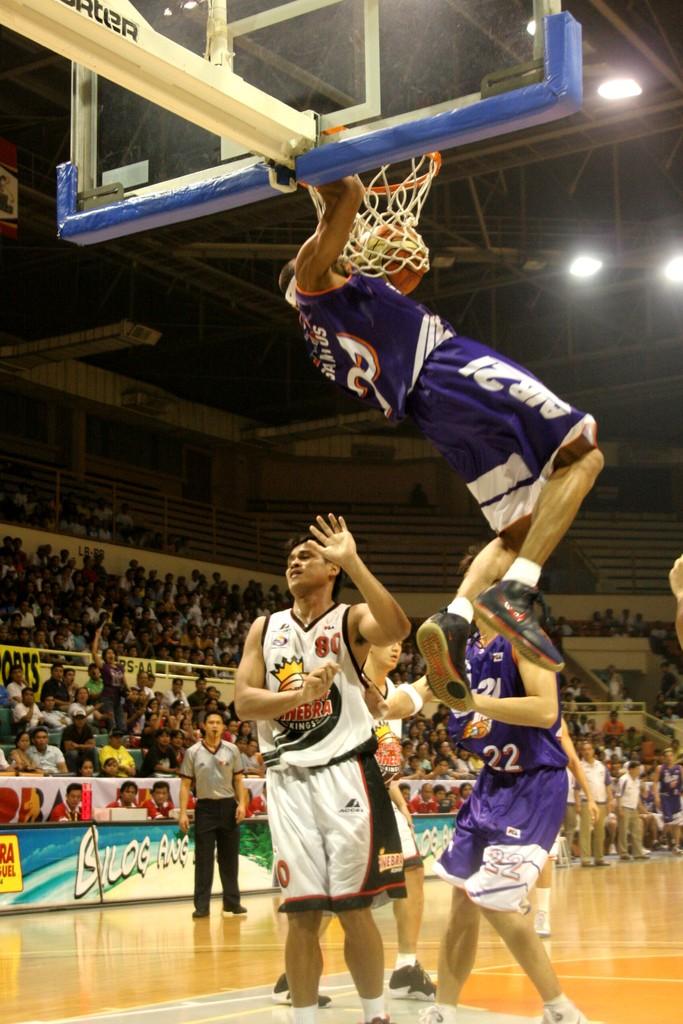What number does the player in the white shirt wear?
Provide a succinct answer. 80. 